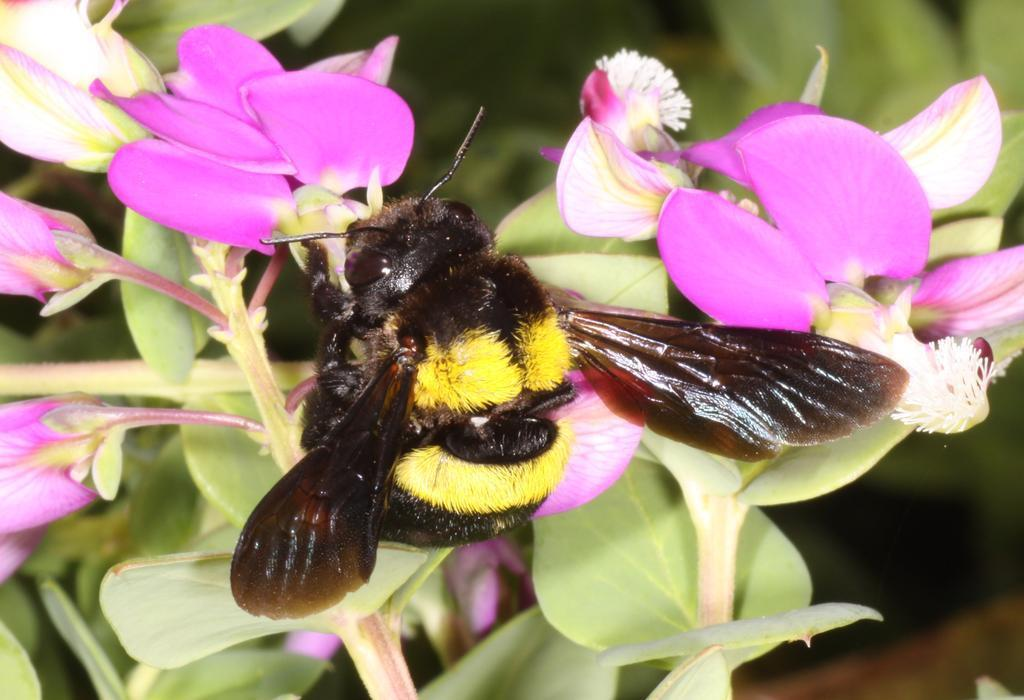What is the main subject of the image? There is a bee on a flower in the image. What else can be seen in the image besides the bee? There are leaves of a plant in the image. Can you describe the background of the image? The background of the image is blurry. How many shoes can be seen in the image? There are no shoes present in the image. 